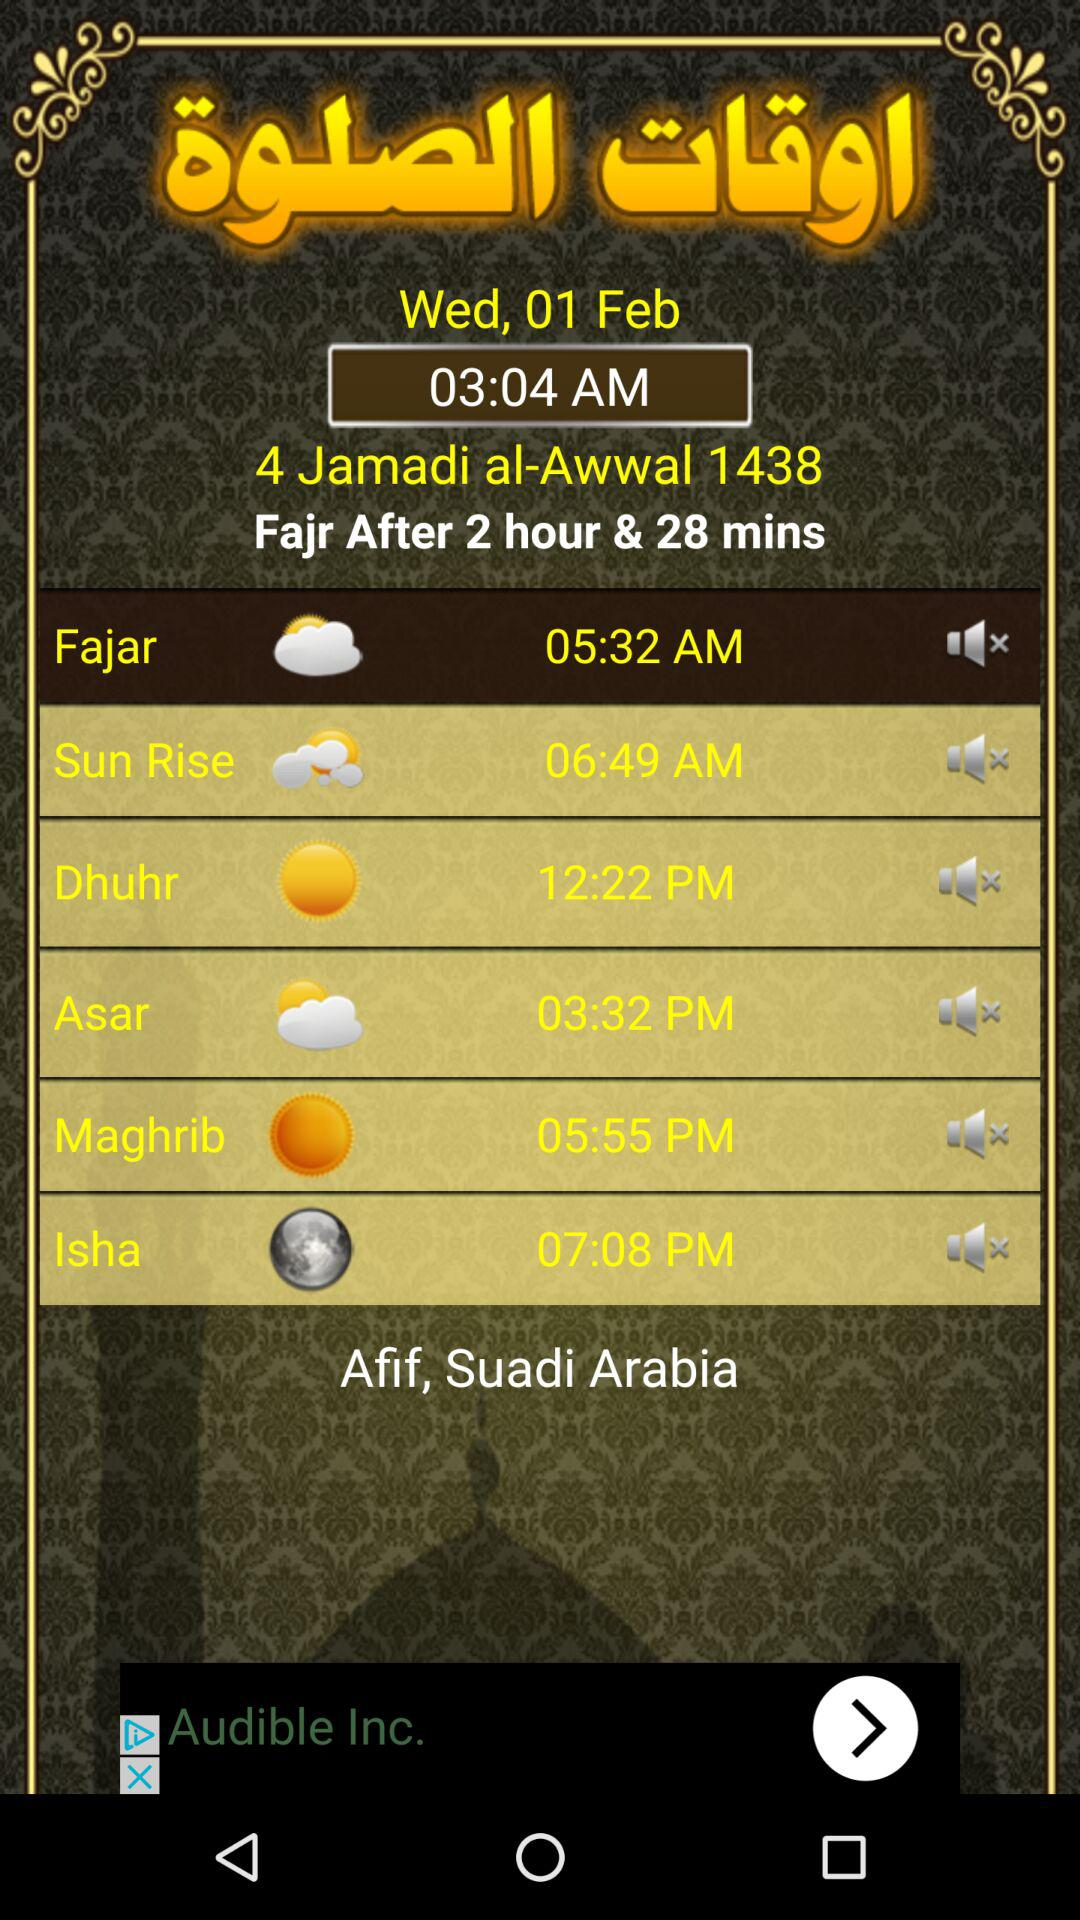What day is it on the mentioned date? The day is Wednesday. 